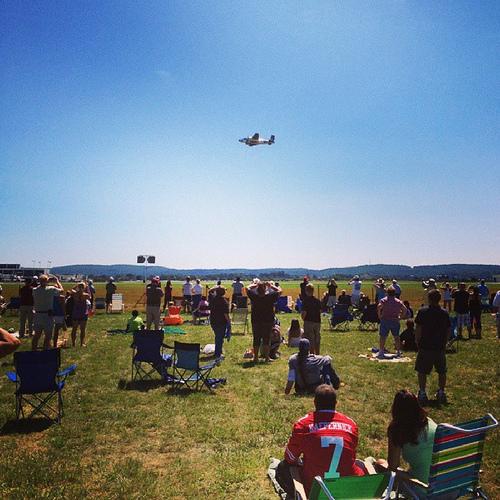What kind of event is being depicted in the image? The image appears to depict an air show, as there is a plane flying overhead and a crowd of people watching from the ground. What is the weather like during this event? The weather seems to be clear and sunny, with blue skies and no visible clouds. 